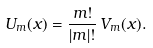Convert formula to latex. <formula><loc_0><loc_0><loc_500><loc_500>U _ { m } ( x ) = \frac { { m } ! } { | m | ! } \, V _ { m } ( x ) .</formula> 